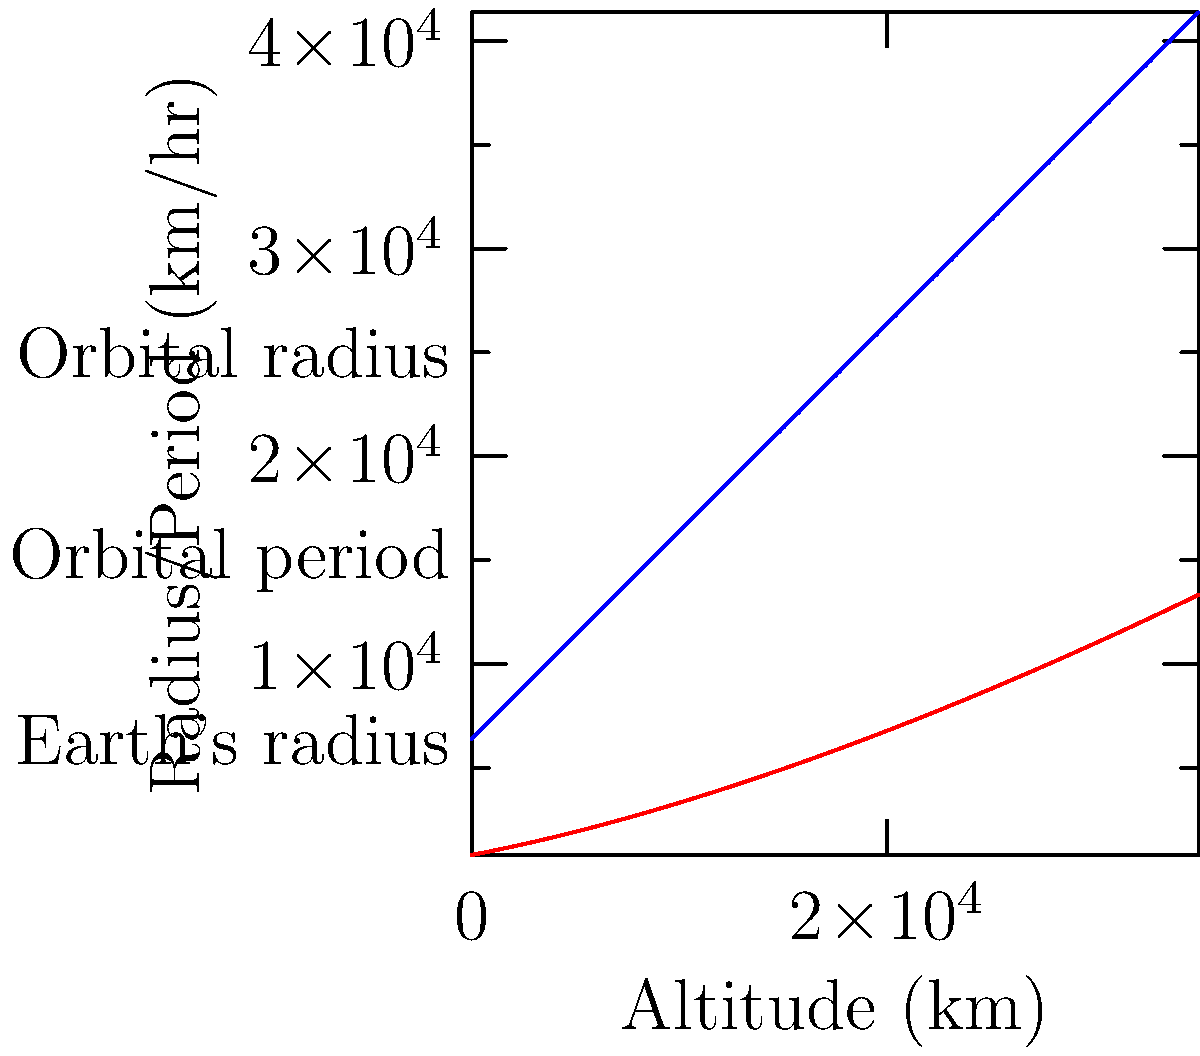As a retired NASA engineer, you're asked to help calculate the orbital period of a satellite. Given that the orbital period $T$ (in hours) of a satellite at altitude $h$ (in km) above Earth's surface is given by the equation:

$$T = 2\pi \sqrt{\frac{(R_E + h)^3}{GM_E}}$$

where $R_E = 6371$ km (Earth's radius) and $\frac{GM_E}{(2\pi)^2} = 1.00748 \times 10^3$ km³/hr², what is the orbital period of a satellite at an altitude of 20,000 km? Round your answer to the nearest hour. Let's approach this step-by-step:

1) We're given the equation: $T = 2\pi \sqrt{\frac{(R_E + h)^3}{GM_E}}$

2) We know:
   $R_E = 6371$ km
   $h = 20000$ km
   $\frac{GM_E}{(2\pi)^2} = 1.00748 \times 10^3$ km³/hr²

3) Let's substitute these values:

   $T = 2\pi \sqrt{\frac{(6371 + 20000)^3}{(2\pi)^2 \cdot 1.00748 \times 10^3}}$

4) Simplify inside the parentheses:
   
   $T = 2\pi \sqrt{\frac{26371^3}{(2\pi)^2 \cdot 1.00748 \times 10^3}}$

5) Calculate $26371^3$:
   
   $T = 2\pi \sqrt{\frac{18315608185291}{(2\pi)^2 \cdot 1.00748 \times 10^3}}$

6) Divide by $(2\pi)^2 \cdot 1.00748 \times 10^3$:
   
   $T = 2\pi \sqrt{28756.05}$

7) Calculate the square root:
   
   $T = 2\pi \cdot 169.58$

8) Multiply by $2\pi$:
   
   $T = 1065.73$ hours

9) Rounding to the nearest hour:
   
   $T \approx 1066$ hours
Answer: 1066 hours 